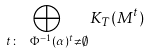Convert formula to latex. <formula><loc_0><loc_0><loc_500><loc_500>\bigoplus _ { t \colon \ \Phi ^ { - 1 } ( \alpha ) ^ { t } \neq \emptyset } K _ { T } ( M ^ { t } )</formula> 